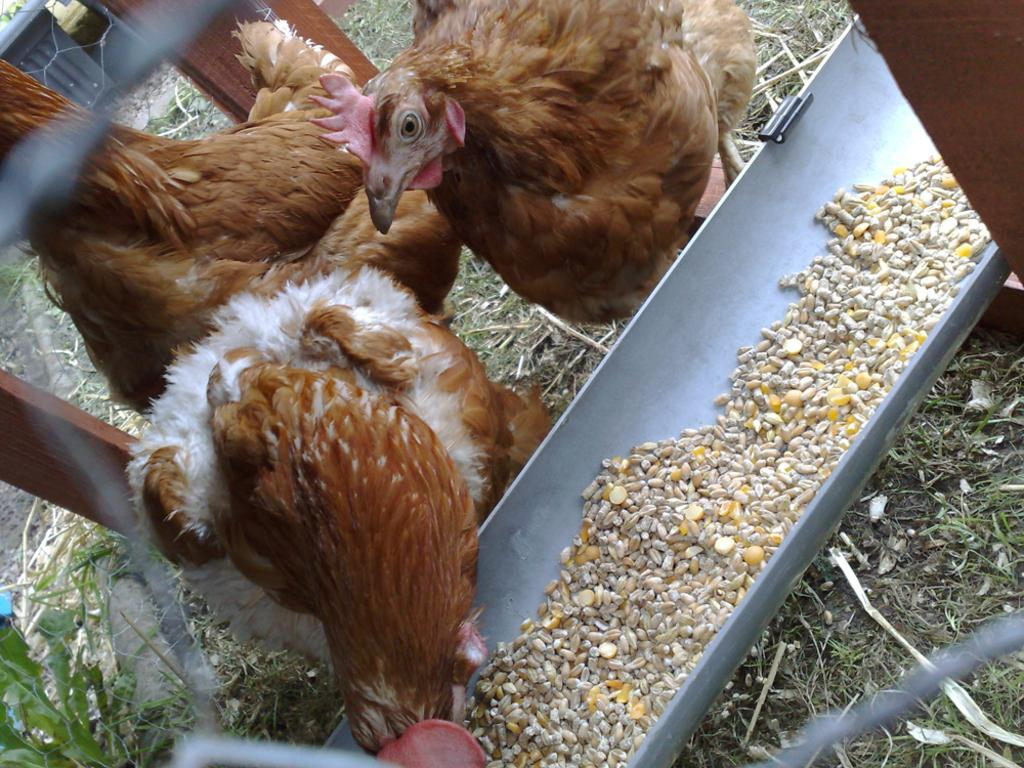What animals can be seen on the ground in the image? There are hens on the ground in the image. What object is present for the hens to eat from? There is a feeding tray in the image. What is inside the feeding tray? The feeding tray contains food items. What type of natural environment is visible in the image? There is grass and plants visible in the image. What additional objects can be seen in the image? There are wooden sticks in the image. What type of alarm can be heard going off in the image? There is no alarm present in the image, so it cannot be heard. 